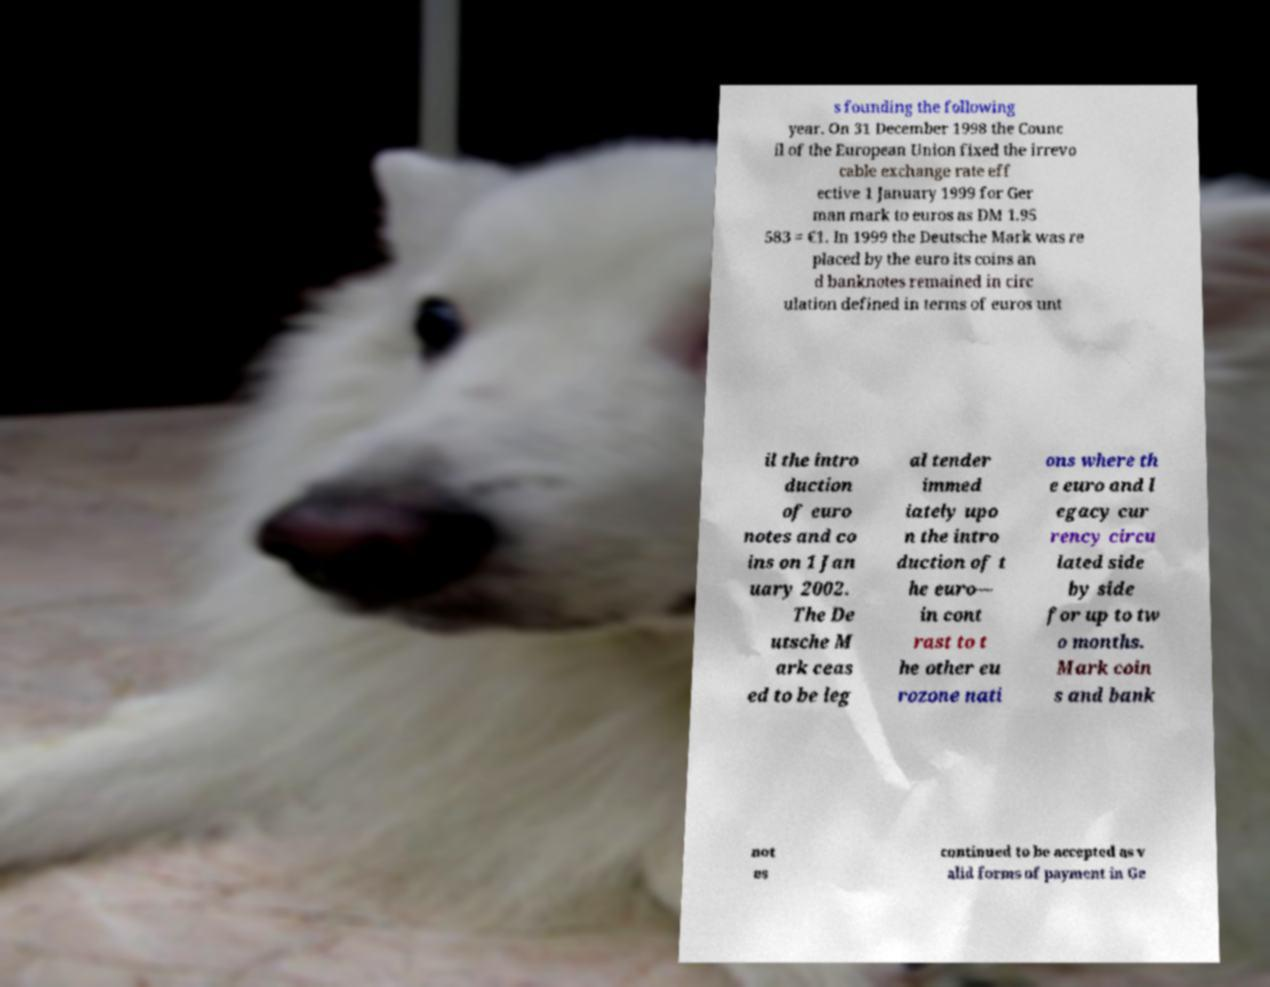Could you extract and type out the text from this image? s founding the following year. On 31 December 1998 the Counc il of the European Union fixed the irrevo cable exchange rate eff ective 1 January 1999 for Ger man mark to euros as DM 1.95 583 = €1. In 1999 the Deutsche Mark was re placed by the euro its coins an d banknotes remained in circ ulation defined in terms of euros unt il the intro duction of euro notes and co ins on 1 Jan uary 2002. The De utsche M ark ceas ed to be leg al tender immed iately upo n the intro duction of t he euro— in cont rast to t he other eu rozone nati ons where th e euro and l egacy cur rency circu lated side by side for up to tw o months. Mark coin s and bank not es continued to be accepted as v alid forms of payment in Ge 